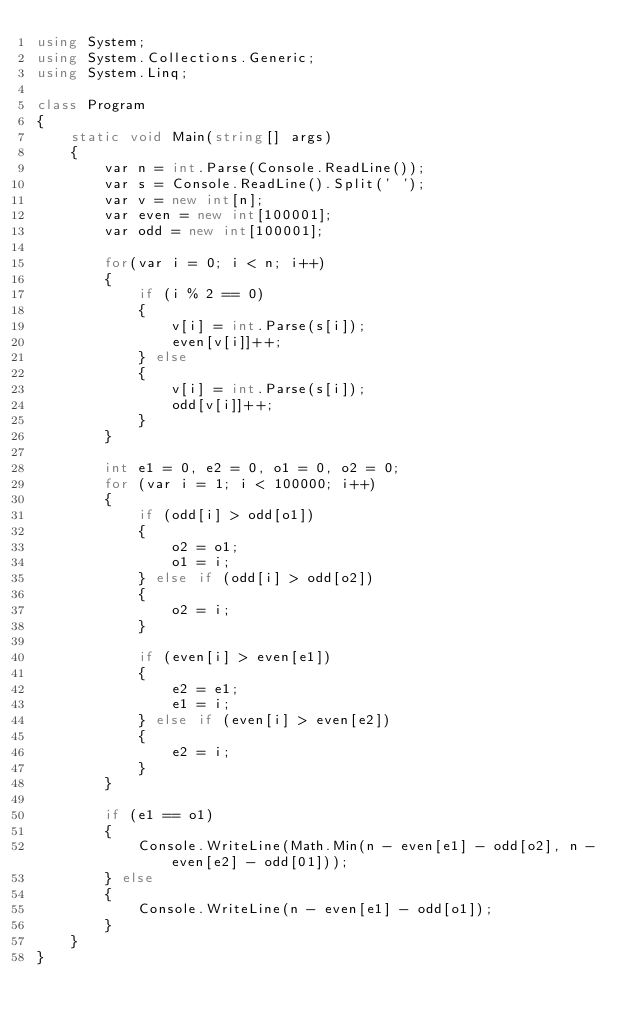Convert code to text. <code><loc_0><loc_0><loc_500><loc_500><_C#_>using System;
using System.Collections.Generic;
using System.Linq;

class Program
{
    static void Main(string[] args)
    {
        var n = int.Parse(Console.ReadLine());
        var s = Console.ReadLine().Split(' ');
        var v = new int[n];
        var even = new int[100001];
        var odd = new int[100001];

        for(var i = 0; i < n; i++)
        {
            if (i % 2 == 0)
            {
                v[i] = int.Parse(s[i]);
                even[v[i]]++;
            } else
            {
                v[i] = int.Parse(s[i]);
                odd[v[i]]++;
            }
        }

        int e1 = 0, e2 = 0, o1 = 0, o2 = 0;
        for (var i = 1; i < 100000; i++)
        {
            if (odd[i] > odd[o1])
            {
                o2 = o1;
                o1 = i;
            } else if (odd[i] > odd[o2])
            {
                o2 = i;
            }

            if (even[i] > even[e1])
            {
                e2 = e1;
                e1 = i;
            } else if (even[i] > even[e2])
            {
                e2 = i;
            }
        }

        if (e1 == o1)
        {
            Console.WriteLine(Math.Min(n - even[e1] - odd[o2], n - even[e2] - odd[01]));
        } else
        {
            Console.WriteLine(n - even[e1] - odd[o1]);
        }
    }
}</code> 